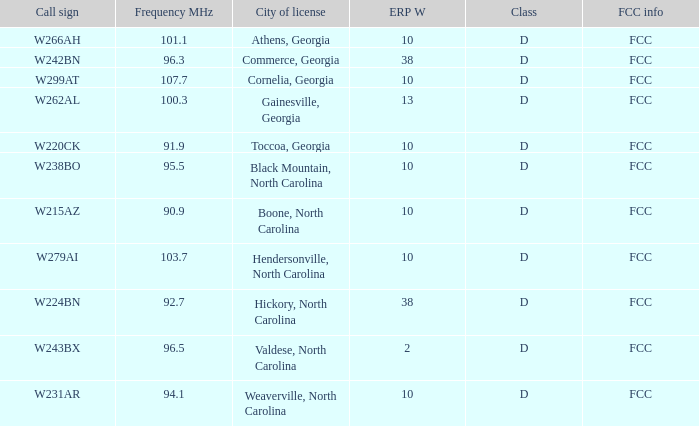Can you give me this table as a dict? {'header': ['Call sign', 'Frequency MHz', 'City of license', 'ERP W', 'Class', 'FCC info'], 'rows': [['W266AH', '101.1', 'Athens, Georgia', '10', 'D', 'FCC'], ['W242BN', '96.3', 'Commerce, Georgia', '38', 'D', 'FCC'], ['W299AT', '107.7', 'Cornelia, Georgia', '10', 'D', 'FCC'], ['W262AL', '100.3', 'Gainesville, Georgia', '13', 'D', 'FCC'], ['W220CK', '91.9', 'Toccoa, Georgia', '10', 'D', 'FCC'], ['W238BO', '95.5', 'Black Mountain, North Carolina', '10', 'D', 'FCC'], ['W215AZ', '90.9', 'Boone, North Carolina', '10', 'D', 'FCC'], ['W279AI', '103.7', 'Hendersonville, North Carolina', '10', 'D', 'FCC'], ['W224BN', '92.7', 'Hickory, North Carolina', '38', 'D', 'FCC'], ['W243BX', '96.5', 'Valdese, North Carolina', '2', 'D', 'FCC'], ['W231AR', '94.1', 'Weaverville, North Carolina', '10', 'D', 'FCC']]} Where can a frequency higher than 94.1 be found in a city? Athens, Georgia, Commerce, Georgia, Cornelia, Georgia, Gainesville, Georgia, Black Mountain, North Carolina, Hendersonville, North Carolina, Valdese, North Carolina. 